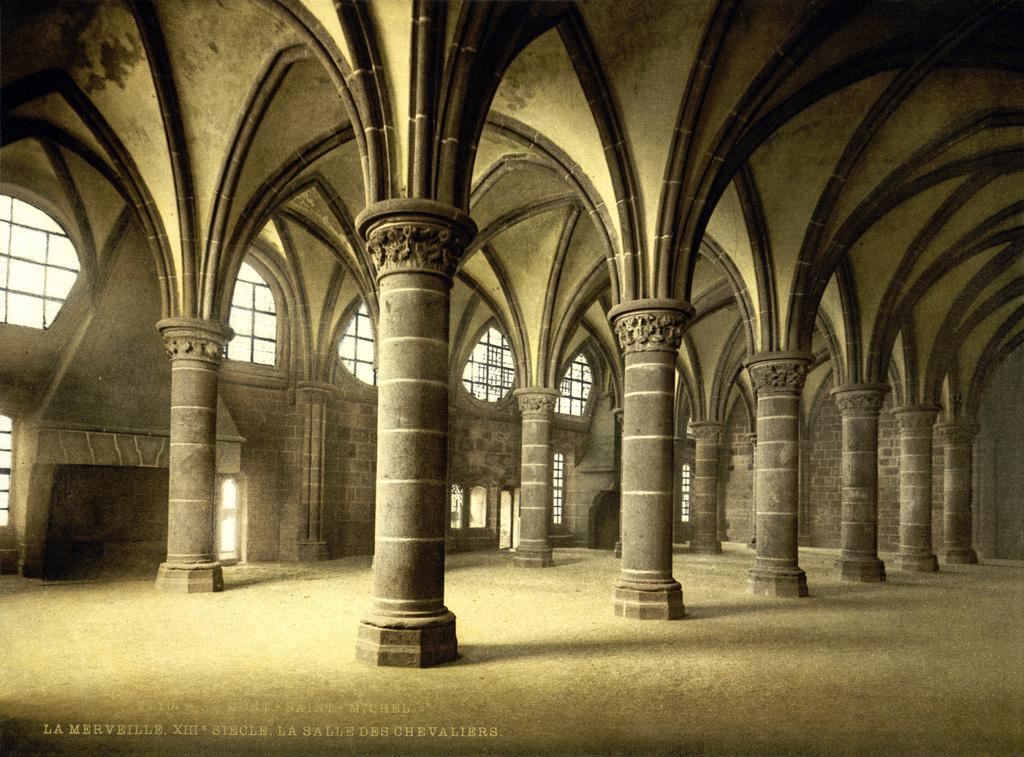Can you describe this image briefly? In this image we can see pillars and windows. There are lights. 